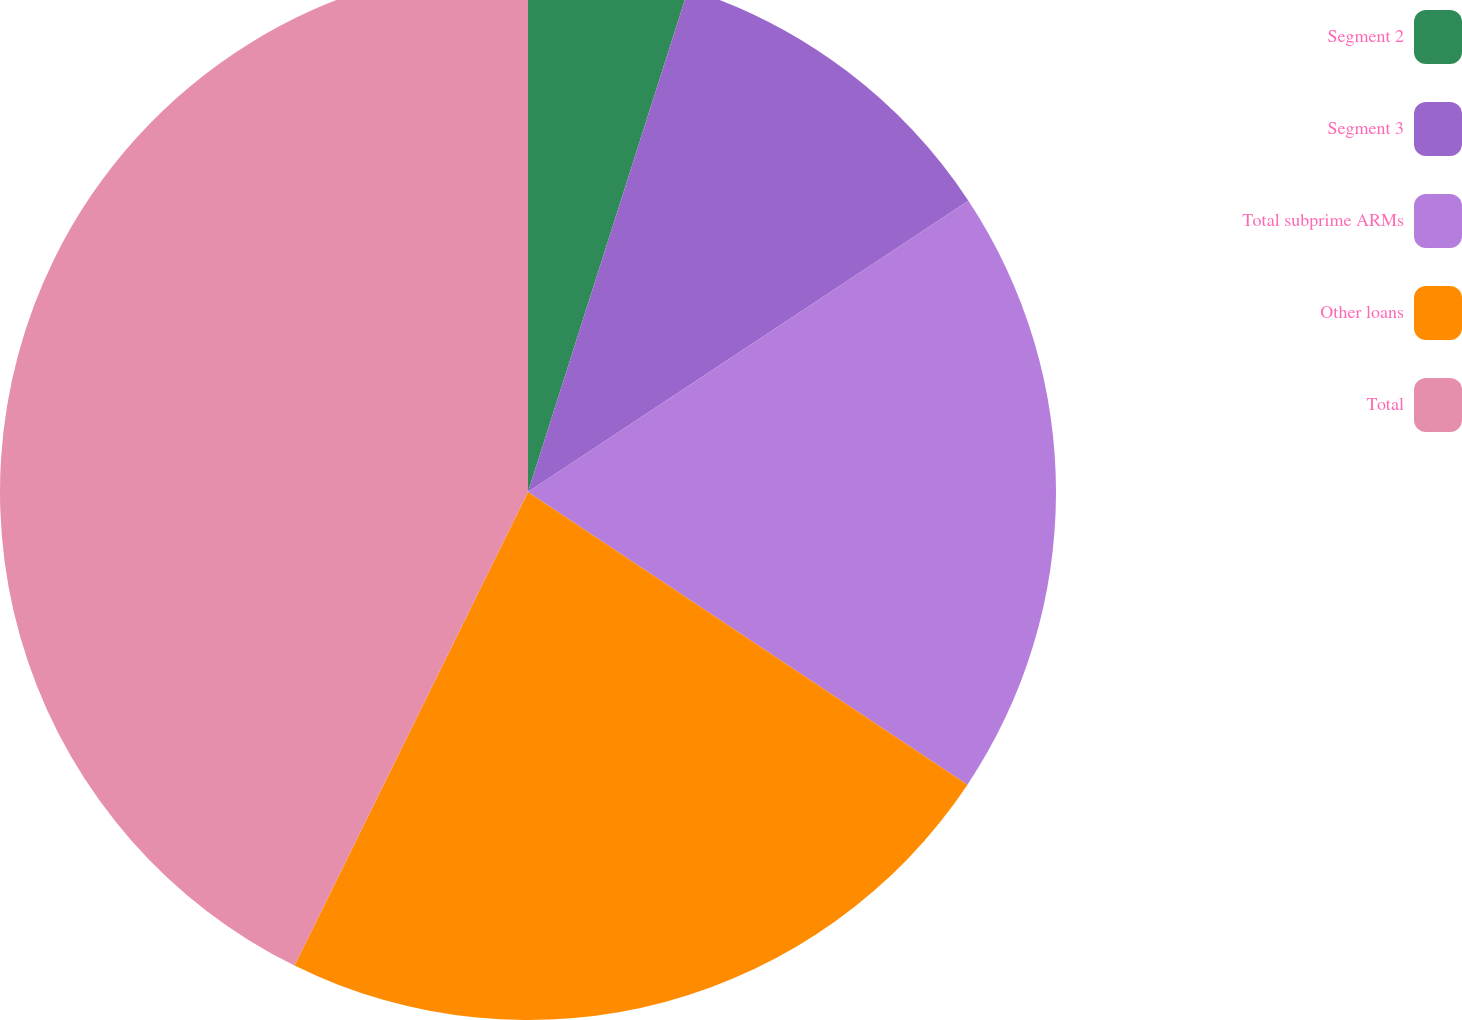Convert chart to OTSL. <chart><loc_0><loc_0><loc_500><loc_500><pie_chart><fcel>Segment 2<fcel>Segment 3<fcel>Total subprime ARMs<fcel>Other loans<fcel>Total<nl><fcel>4.91%<fcel>10.79%<fcel>18.65%<fcel>22.94%<fcel>42.71%<nl></chart> 